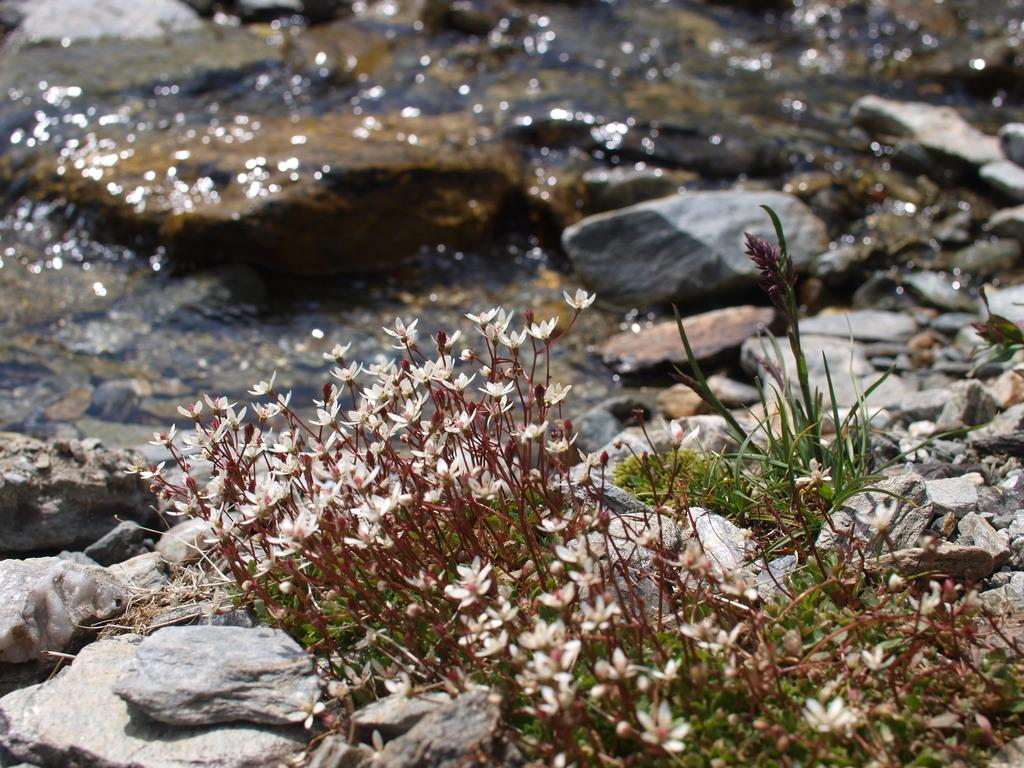What can be seen in the foreground of the picture? In the foreground of the picture, there are stones, grass, plants, and flowers. Can you describe the elements in the background of the image? The background of the image is blurred, but it contains stones and water. What is the weather like in the image? It is sunny in the image. What type of airplane is flying over the flowers in the image? There is no airplane present in the image; it only features stones, grass, plants, and flowers in the foreground, and a blurred background with stones and water. What event is taking place in the image? There is no specific event depicted in the image; it simply shows a natural scene with stones, grass, plants, flowers, and a blurred background with stones and water. 